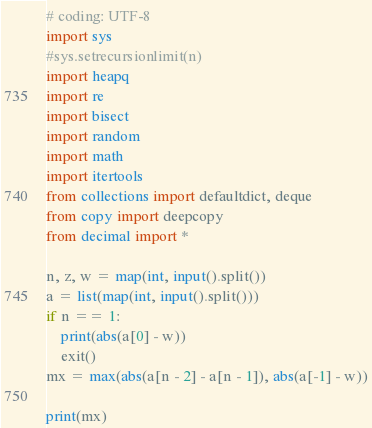Convert code to text. <code><loc_0><loc_0><loc_500><loc_500><_Python_># coding: UTF-8
import sys
#sys.setrecursionlimit(n)
import heapq
import re
import bisect
import random
import math
import itertools
from collections import defaultdict, deque
from copy import deepcopy
from decimal import *

n, z, w = map(int, input().split())
a = list(map(int, input().split()))
if n == 1:
    print(abs(a[0] - w))
    exit()
mx = max(abs(a[n - 2] - a[n - 1]), abs(a[-1] - w))

print(mx)
</code> 